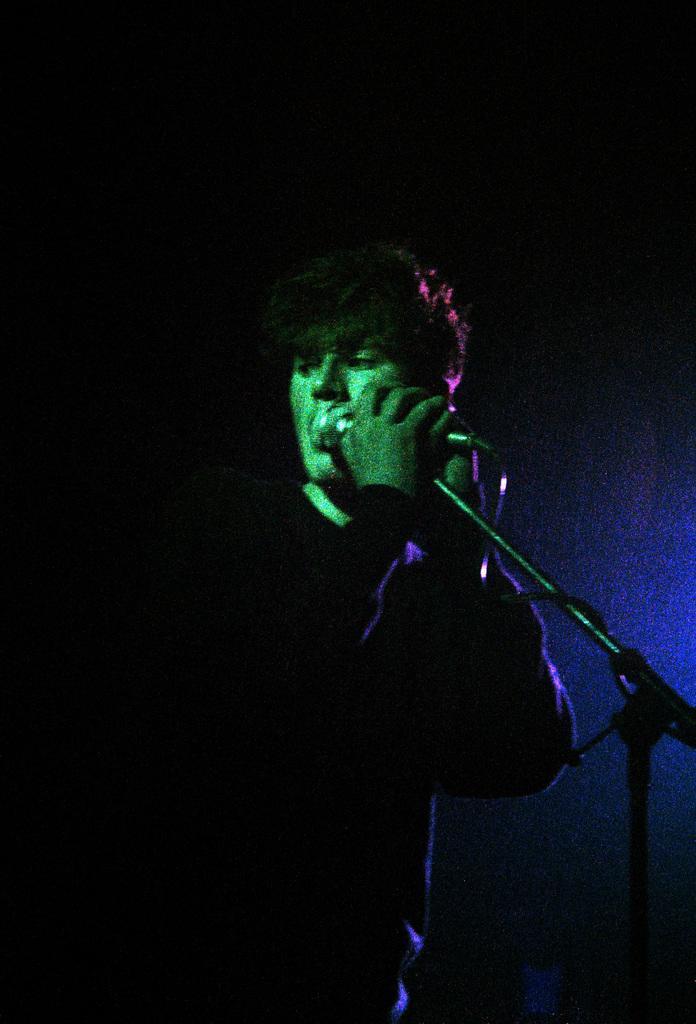Could you give a brief overview of what you see in this image? This is an image clicked in the dark. Here I can see a person standing and holding a mike stand. The background is in black color. 